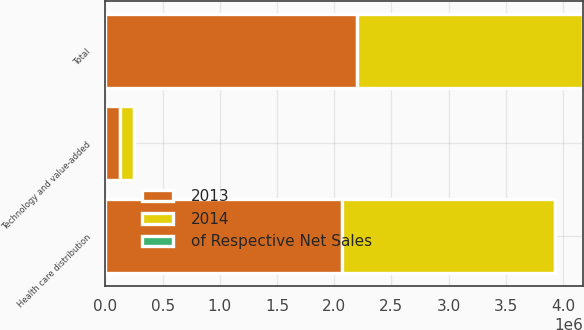<chart> <loc_0><loc_0><loc_500><loc_500><stacked_bar_chart><ecel><fcel>Health care distribution<fcel>Technology and value-added<fcel>Total<nl><fcel>2013<fcel>2.06842e+06<fcel>127754<fcel>2.19617e+06<nl><fcel>of Respective Net Sales<fcel>20.6<fcel>36.6<fcel>21.2<nl><fcel>2014<fcel>1.86067e+06<fcel>118290<fcel>1.97896e+06<nl></chart> 